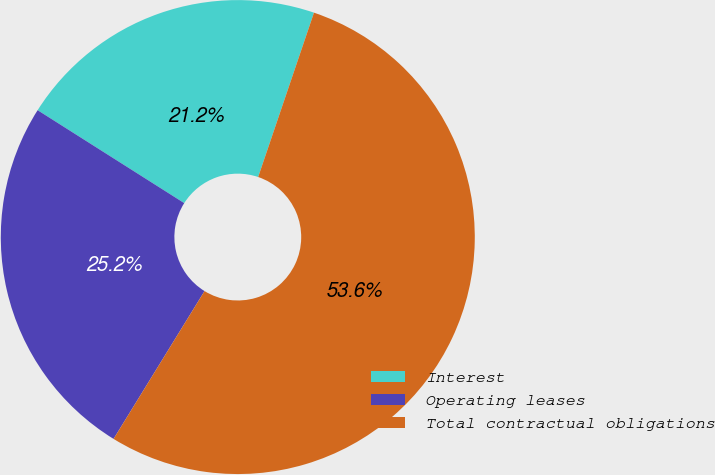<chart> <loc_0><loc_0><loc_500><loc_500><pie_chart><fcel>Interest<fcel>Operating leases<fcel>Total contractual obligations<nl><fcel>21.22%<fcel>25.21%<fcel>53.57%<nl></chart> 